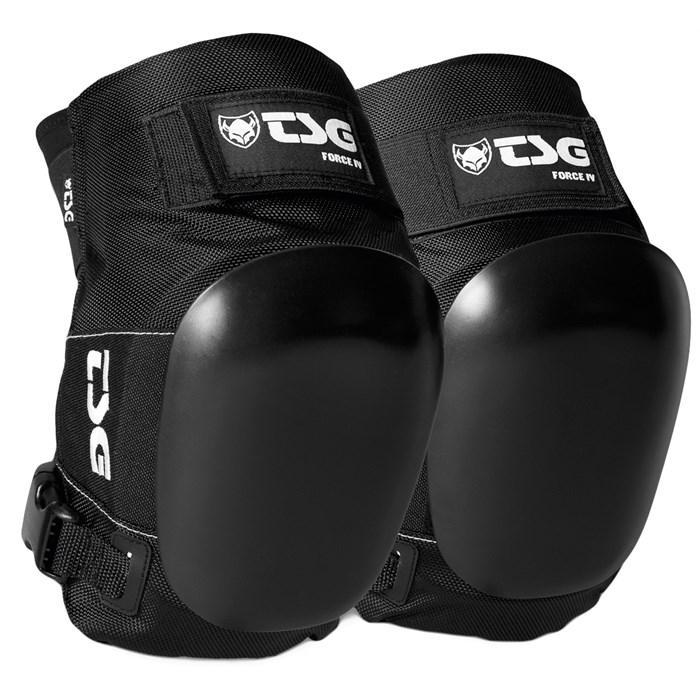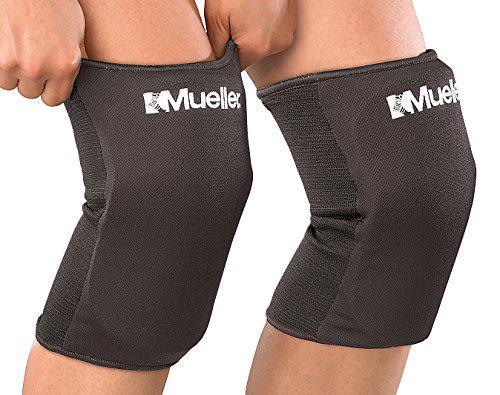The first image is the image on the left, the second image is the image on the right. Evaluate the accuracy of this statement regarding the images: "Each image shows a pair of black knee pads.". Is it true? Answer yes or no. Yes. The first image is the image on the left, the second image is the image on the right. Considering the images on both sides, is "One of the pairs of pads is incomplete." valid? Answer yes or no. No. The first image is the image on the left, the second image is the image on the right. For the images displayed, is the sentence "An image shows a pair of unworn, smooth black kneepads with no texture turned rightward." factually correct? Answer yes or no. Yes. The first image is the image on the left, the second image is the image on the right. Analyze the images presented: Is the assertion "The knee pads in the image on the right have no white markings." valid? Answer yes or no. No. 